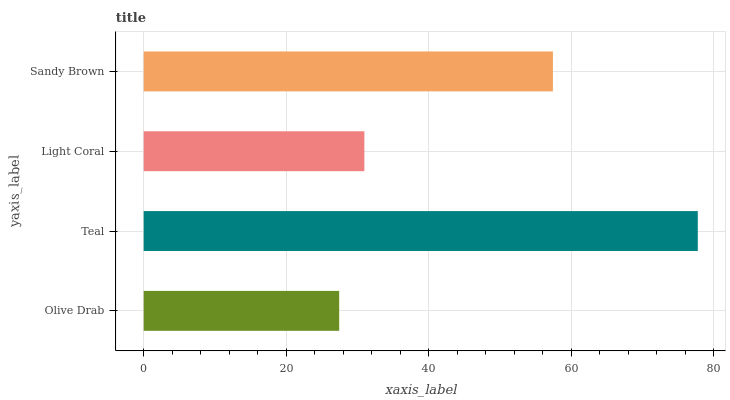Is Olive Drab the minimum?
Answer yes or no. Yes. Is Teal the maximum?
Answer yes or no. Yes. Is Light Coral the minimum?
Answer yes or no. No. Is Light Coral the maximum?
Answer yes or no. No. Is Teal greater than Light Coral?
Answer yes or no. Yes. Is Light Coral less than Teal?
Answer yes or no. Yes. Is Light Coral greater than Teal?
Answer yes or no. No. Is Teal less than Light Coral?
Answer yes or no. No. Is Sandy Brown the high median?
Answer yes or no. Yes. Is Light Coral the low median?
Answer yes or no. Yes. Is Light Coral the high median?
Answer yes or no. No. Is Teal the low median?
Answer yes or no. No. 